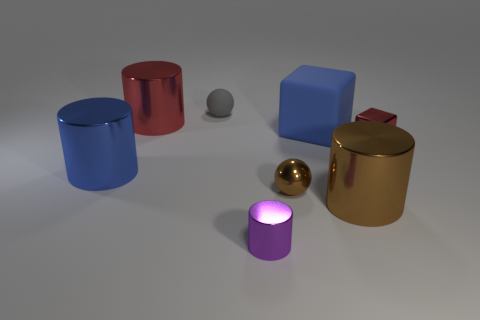There is a purple metallic object that is the same shape as the big brown thing; what is its size?
Ensure brevity in your answer.  Small. What number of tiny gray cylinders have the same material as the big red cylinder?
Make the answer very short. 0. There is a tiny object that is behind the tiny red metallic thing in front of the large blue block; is there a gray rubber ball behind it?
Your answer should be compact. No. What is the shape of the blue rubber thing?
Give a very brief answer. Cube. Is the material of the red object that is to the right of the big blue cube the same as the big blue thing on the left side of the tiny purple cylinder?
Give a very brief answer. Yes. How many small metal spheres are the same color as the tiny cylinder?
Give a very brief answer. 0. What shape is the large thing that is behind the shiny cube and in front of the large red cylinder?
Your answer should be very brief. Cube. What color is the object that is both right of the red cylinder and behind the blue cube?
Your response must be concise. Gray. Are there more metallic blocks that are to the left of the red shiny cylinder than blue cylinders that are behind the matte ball?
Your response must be concise. No. The big metal thing on the left side of the red cylinder is what color?
Your answer should be compact. Blue. 